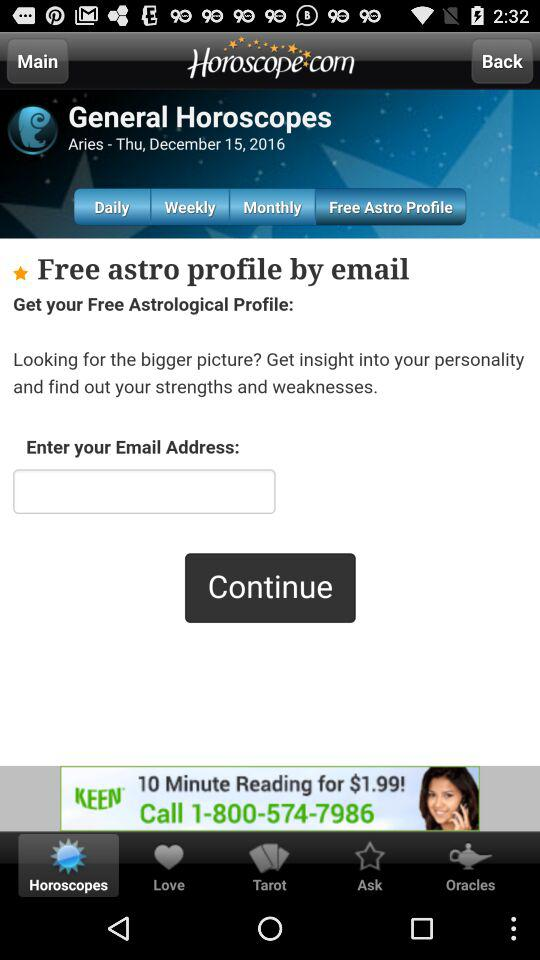Which option was selected in "General Horoscopes"? The selected option in "General Horoscopes" was "Free Astro Profile". 